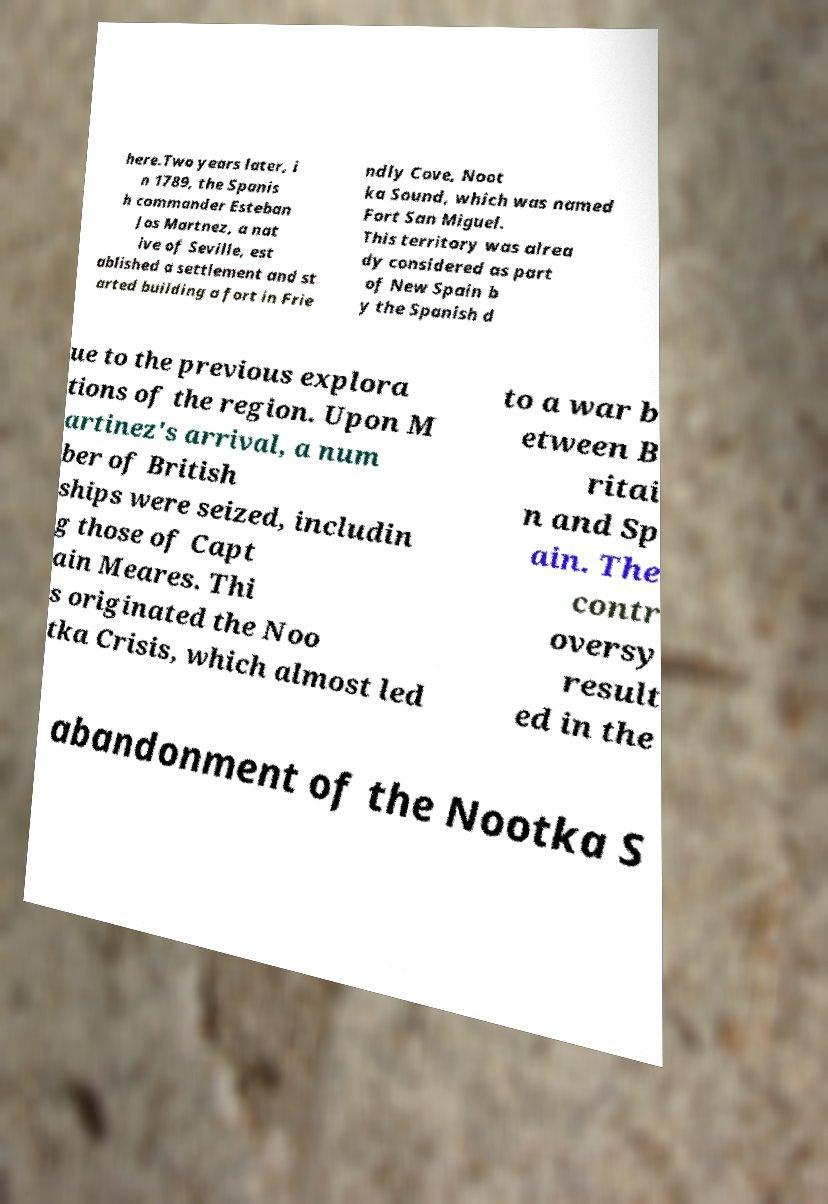Can you read and provide the text displayed in the image?This photo seems to have some interesting text. Can you extract and type it out for me? here.Two years later, i n 1789, the Spanis h commander Esteban Jos Martnez, a nat ive of Seville, est ablished a settlement and st arted building a fort in Frie ndly Cove, Noot ka Sound, which was named Fort San Miguel. This territory was alrea dy considered as part of New Spain b y the Spanish d ue to the previous explora tions of the region. Upon M artinez's arrival, a num ber of British ships were seized, includin g those of Capt ain Meares. Thi s originated the Noo tka Crisis, which almost led to a war b etween B ritai n and Sp ain. The contr oversy result ed in the abandonment of the Nootka S 